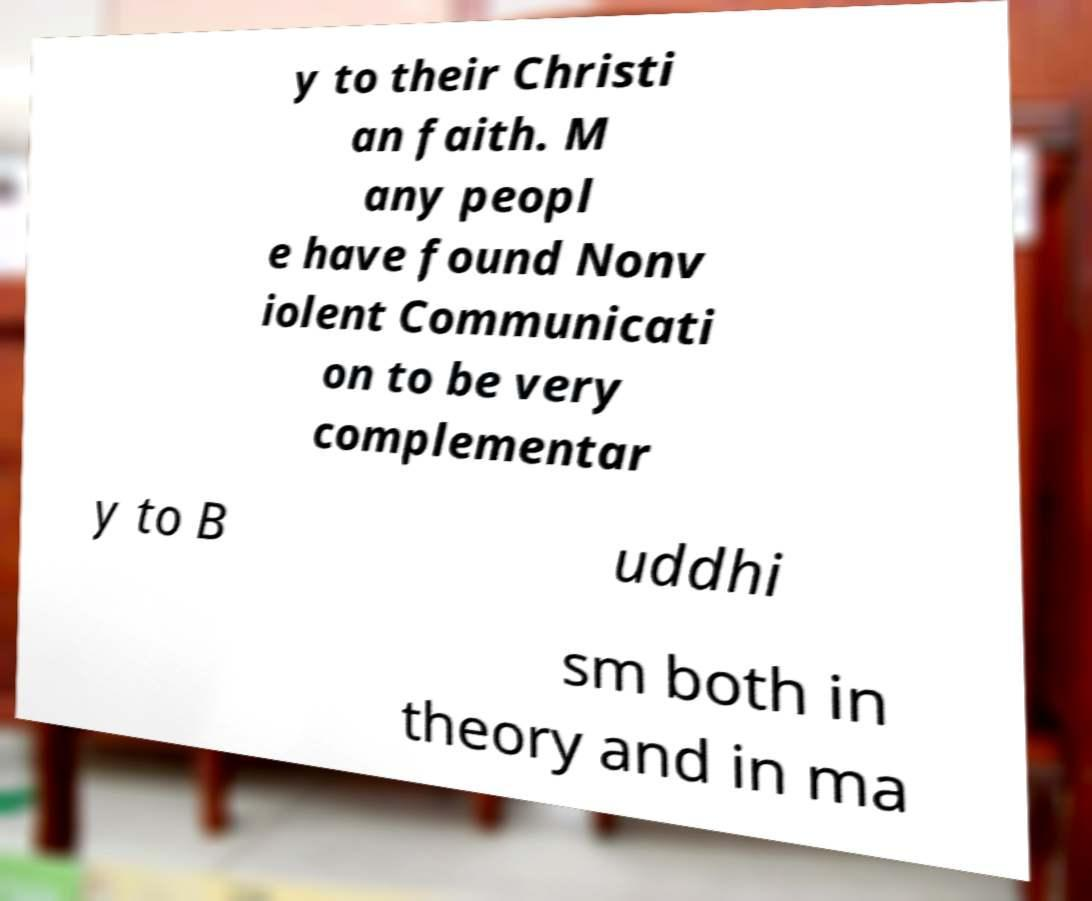Please read and relay the text visible in this image. What does it say? y to their Christi an faith. M any peopl e have found Nonv iolent Communicati on to be very complementar y to B uddhi sm both in theory and in ma 